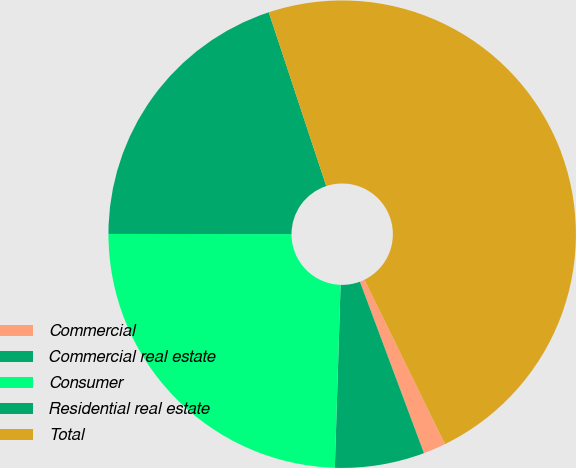<chart> <loc_0><loc_0><loc_500><loc_500><pie_chart><fcel>Commercial<fcel>Commercial real estate<fcel>Consumer<fcel>Residential real estate<fcel>Total<nl><fcel>1.56%<fcel>6.19%<fcel>24.52%<fcel>19.9%<fcel>47.84%<nl></chart> 